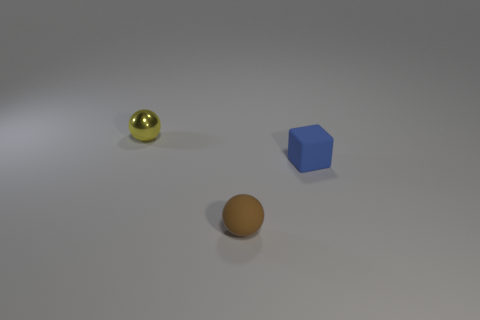Add 2 small matte spheres. How many objects exist? 5 Subtract all spheres. How many objects are left? 1 Subtract all brown blocks. Subtract all cyan spheres. How many blocks are left? 1 Subtract all small cubes. Subtract all yellow shiny objects. How many objects are left? 1 Add 2 brown spheres. How many brown spheres are left? 3 Add 3 metal objects. How many metal objects exist? 4 Subtract 0 gray balls. How many objects are left? 3 